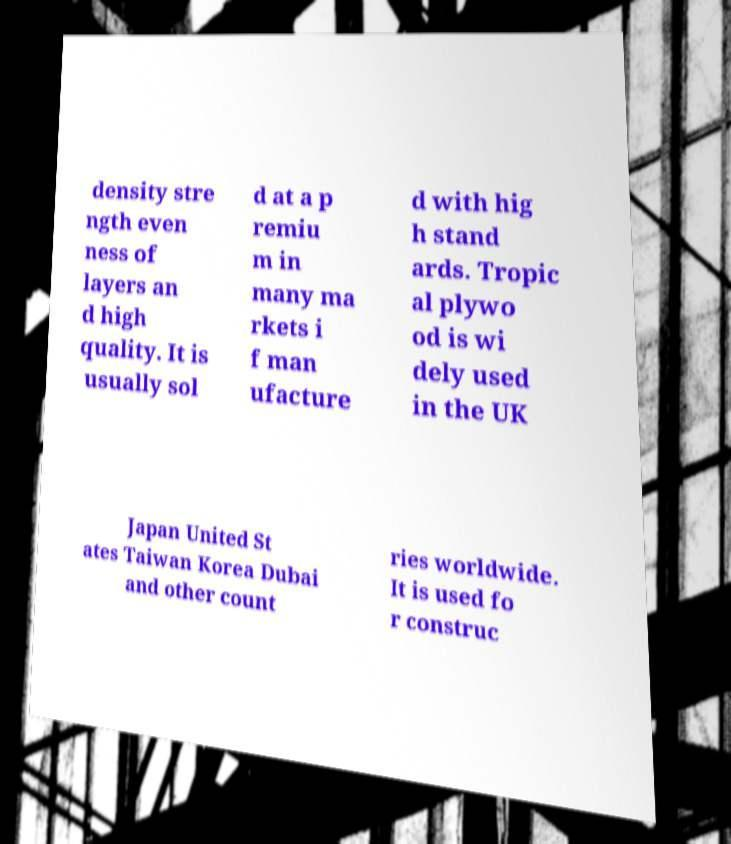Please identify and transcribe the text found in this image. density stre ngth even ness of layers an d high quality. It is usually sol d at a p remiu m in many ma rkets i f man ufacture d with hig h stand ards. Tropic al plywo od is wi dely used in the UK Japan United St ates Taiwan Korea Dubai and other count ries worldwide. It is used fo r construc 